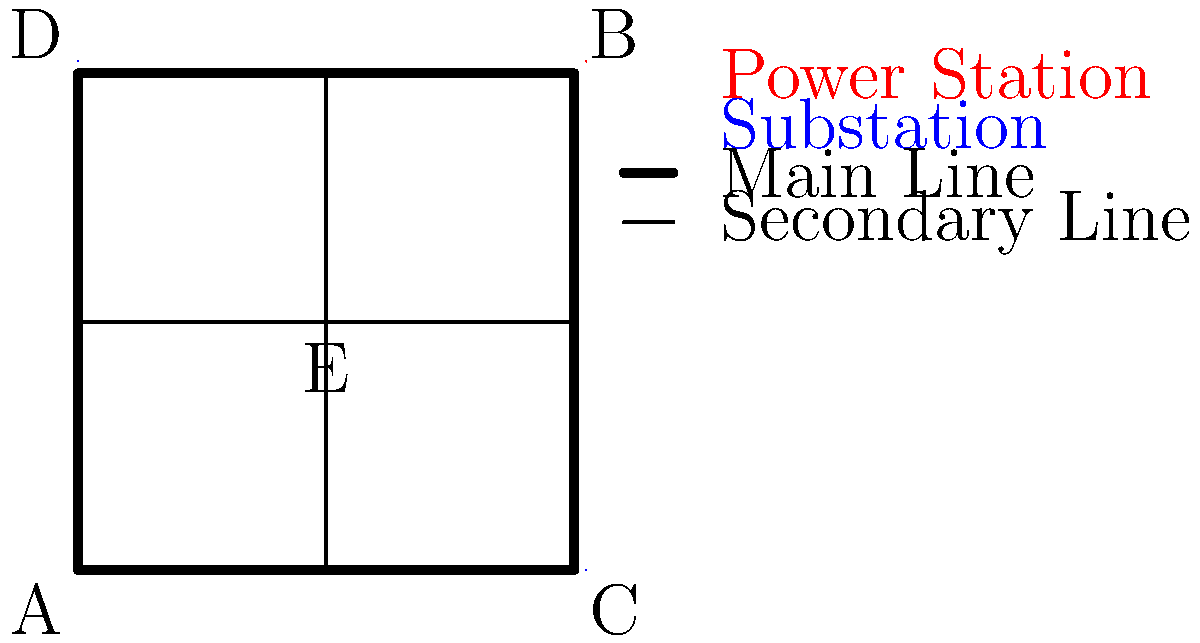As the mayoral candidate, you've obtained this simplified diagram of the city's power grid. Identifying weak points could help you propose improvements and gain public support. Which node in the grid represents the most critical vulnerability, where a failure would cause the most widespread outage? To identify the most critical vulnerability in the power grid, we need to analyze the network structure and the potential impact of failures at each node:

1. Node A and B are power stations, serving as the main sources of electricity.
2. Node C and D are substations, which distribute power from the main stations.
3. Node E is a central junction connecting secondary power lines.

Let's examine the impact of failure at each node:

1. Power Station A: Failure would cut off power to the left half of the grid, affecting nodes C, D, and E.
2. Power Station B: Failure would cut off power to the right half of the grid, affecting nodes C and D.
3. Substation C: Failure would only affect the lower-right area of the grid.
4. Substation D: Failure would only affect the upper-left area of the grid.
5. Junction E: Failure would disconnect the secondary power lines, but main power lines would still function.

The most critical vulnerability is Node E because:
1. It's the central junction connecting all secondary power lines.
2. Its failure would isolate the four corners of the grid from each other.
3. While main power lines would still function, the grid's ability to redistribute power in case of other failures would be severely compromised.
4. Improving this node could enhance the overall resilience of the power grid, making it an ideal focus for a mayoral candidate's infrastructure improvement plan.
Answer: Node E (central junction) 